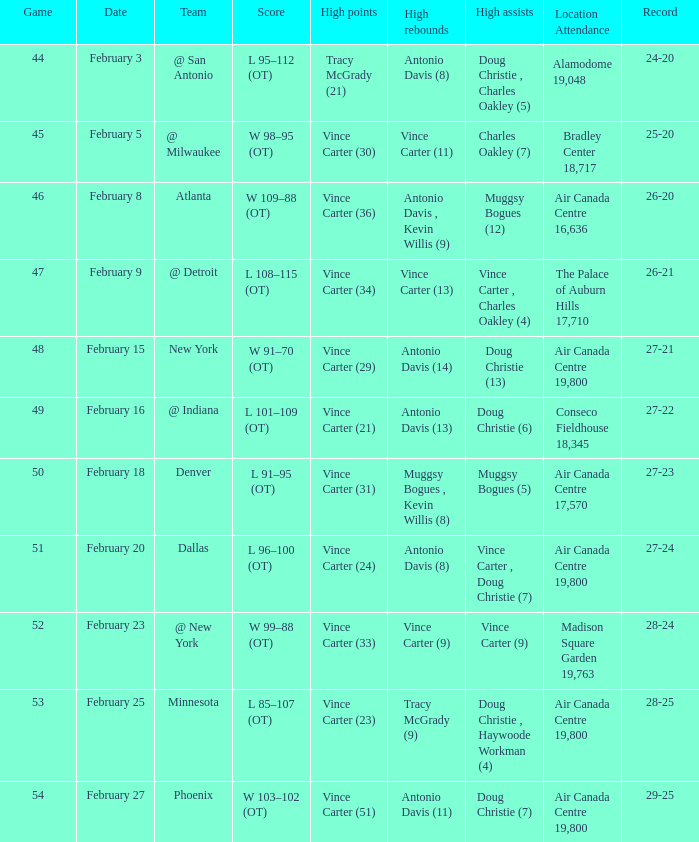How many games were played when the record was 26-21? 1.0. 